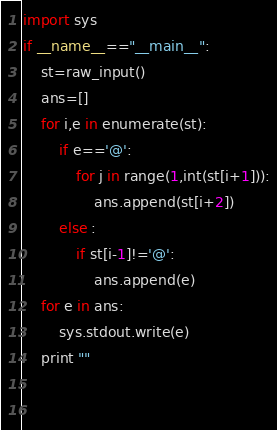Convert code to text. <code><loc_0><loc_0><loc_500><loc_500><_Python_>import sys
if __name__=="__main__":
    st=raw_input()
    ans=[]
    for i,e in enumerate(st):
        if e=='@':
            for j in range(1,int(st[i+1])):
                ans.append(st[i+2])
        else :
            if st[i-1]!='@':
                ans.append(e)
    for e in ans:
        sys.stdout.write(e)
    print ""
    
        </code> 